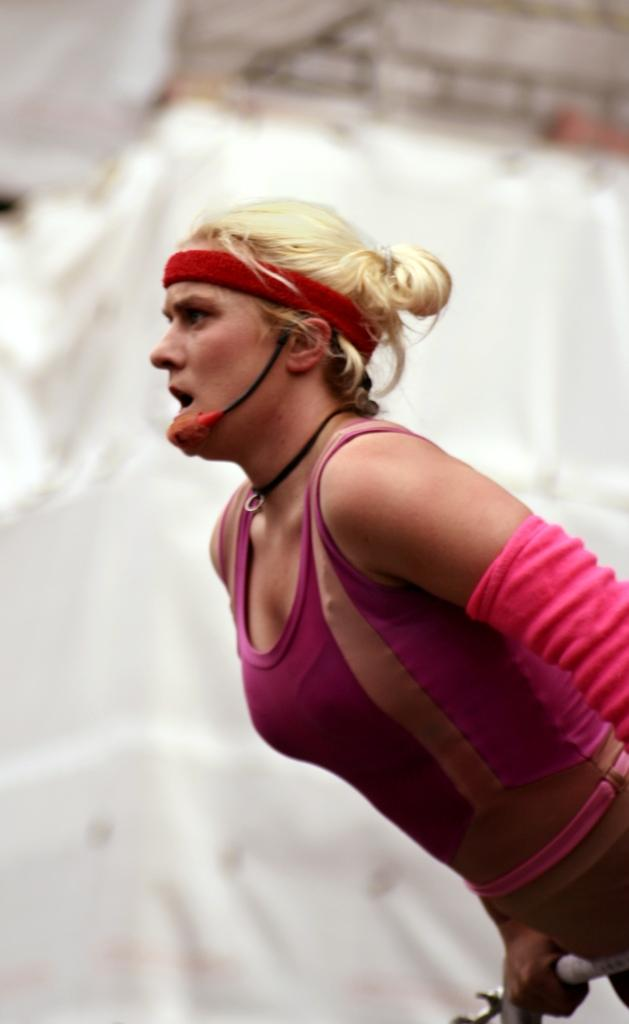Who is the main subject in the image? There is a woman in the image. What is the woman doing in the image? The woman is holding an object. What can be seen in the background of the image? There are objects in the background of the image. How would you describe the background of the image? The background is blurry. What type of coach can be seen in the background of the image? There is no coach present in the image; the background is blurry and only objects can be seen. 